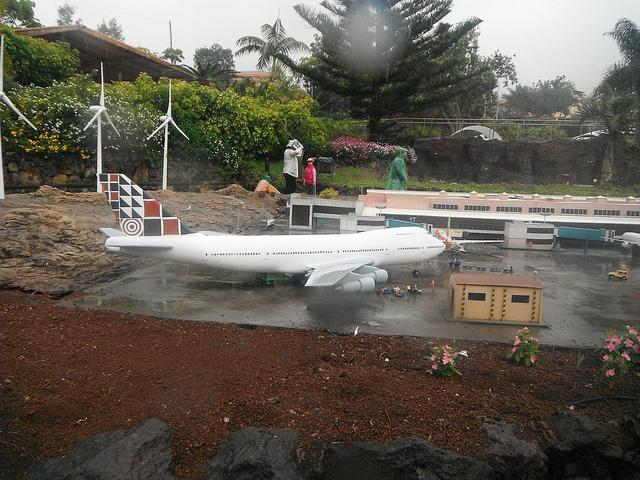What is this place? airport 